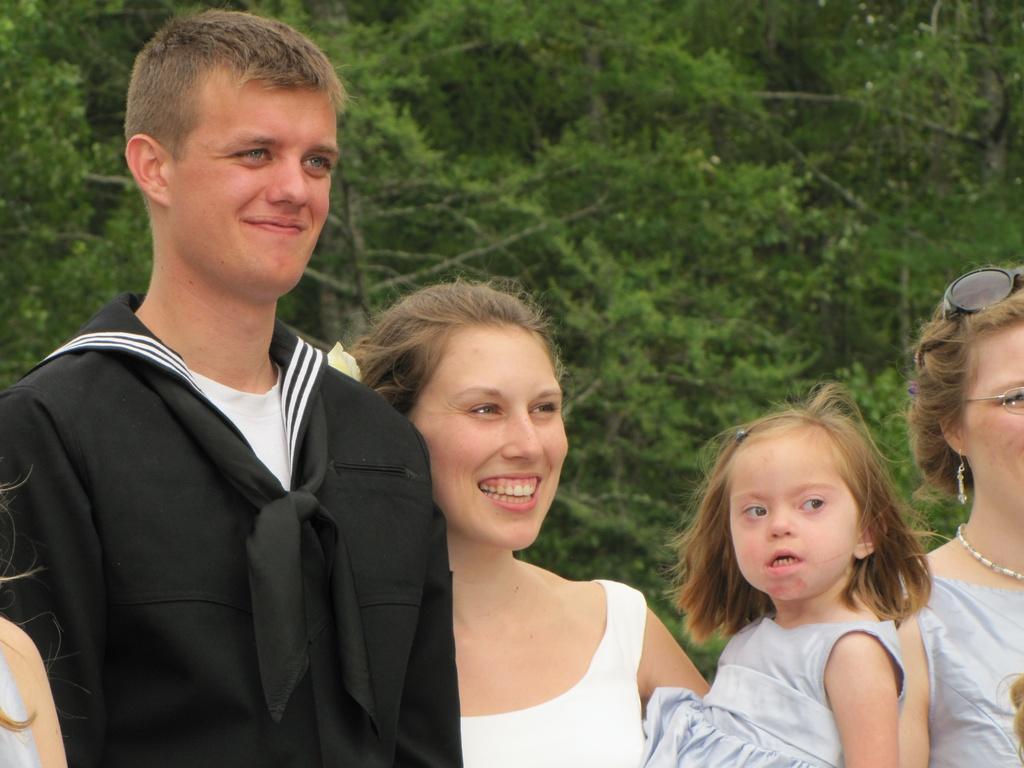Can you describe this image briefly? In the image there are group of people standing and posing for the photo, there are total five people in the image and one person is not clearly visible. 